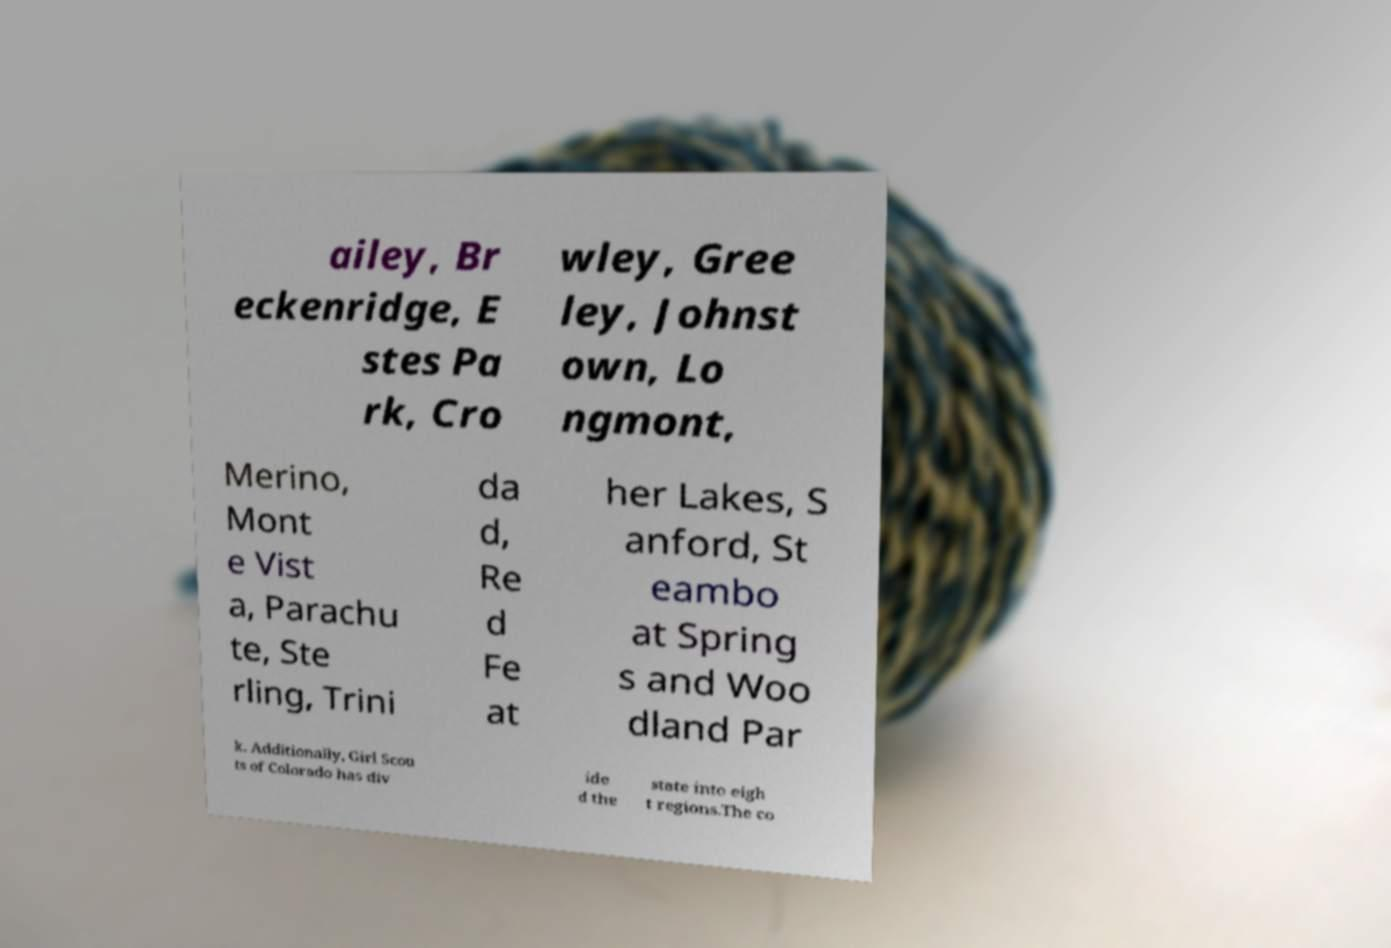Can you read and provide the text displayed in the image?This photo seems to have some interesting text. Can you extract and type it out for me? ailey, Br eckenridge, E stes Pa rk, Cro wley, Gree ley, Johnst own, Lo ngmont, Merino, Mont e Vist a, Parachu te, Ste rling, Trini da d, Re d Fe at her Lakes, S anford, St eambo at Spring s and Woo dland Par k. Additionally, Girl Scou ts of Colorado has div ide d the state into eigh t regions.The co 